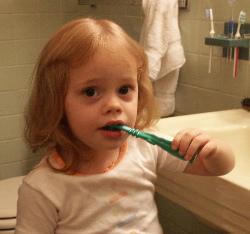What color is the girl's toothbrush?
Answer briefly. Green. What color is the kids shirt?
Concise answer only. White. What kind of sink is that?
Quick response, please. Bathroom. Where are the toothbrushes?
Write a very short answer. On wall. What color hair does the little girl have?
Be succinct. Blonde. What animal is on the end of the toothbrush?
Give a very brief answer. Human. 